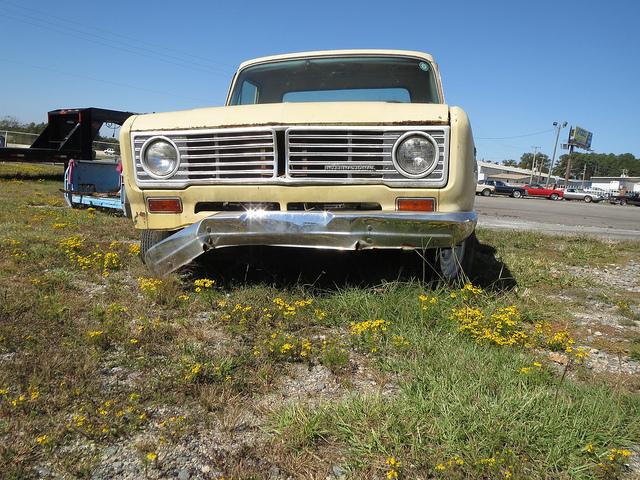What is the year of the vehicle?
Be succinct. 1975. What color is this vehicle?
Answer briefly. Yellow. Is the front bumper falling off?
Answer briefly. Yes. 